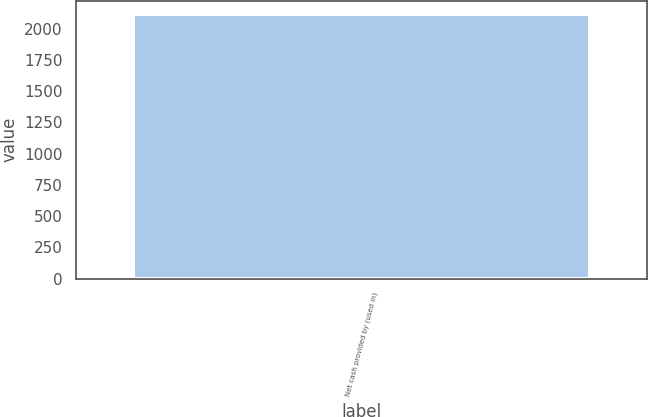<chart> <loc_0><loc_0><loc_500><loc_500><bar_chart><fcel>Net cash provided by (used in)<nl><fcel>2118<nl></chart> 